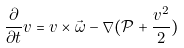Convert formula to latex. <formula><loc_0><loc_0><loc_500><loc_500>\frac { \partial } { \partial t } v = v \times \vec { \omega } - \nabla ( \mathcal { P } + \frac { v ^ { 2 } } { 2 } )</formula> 